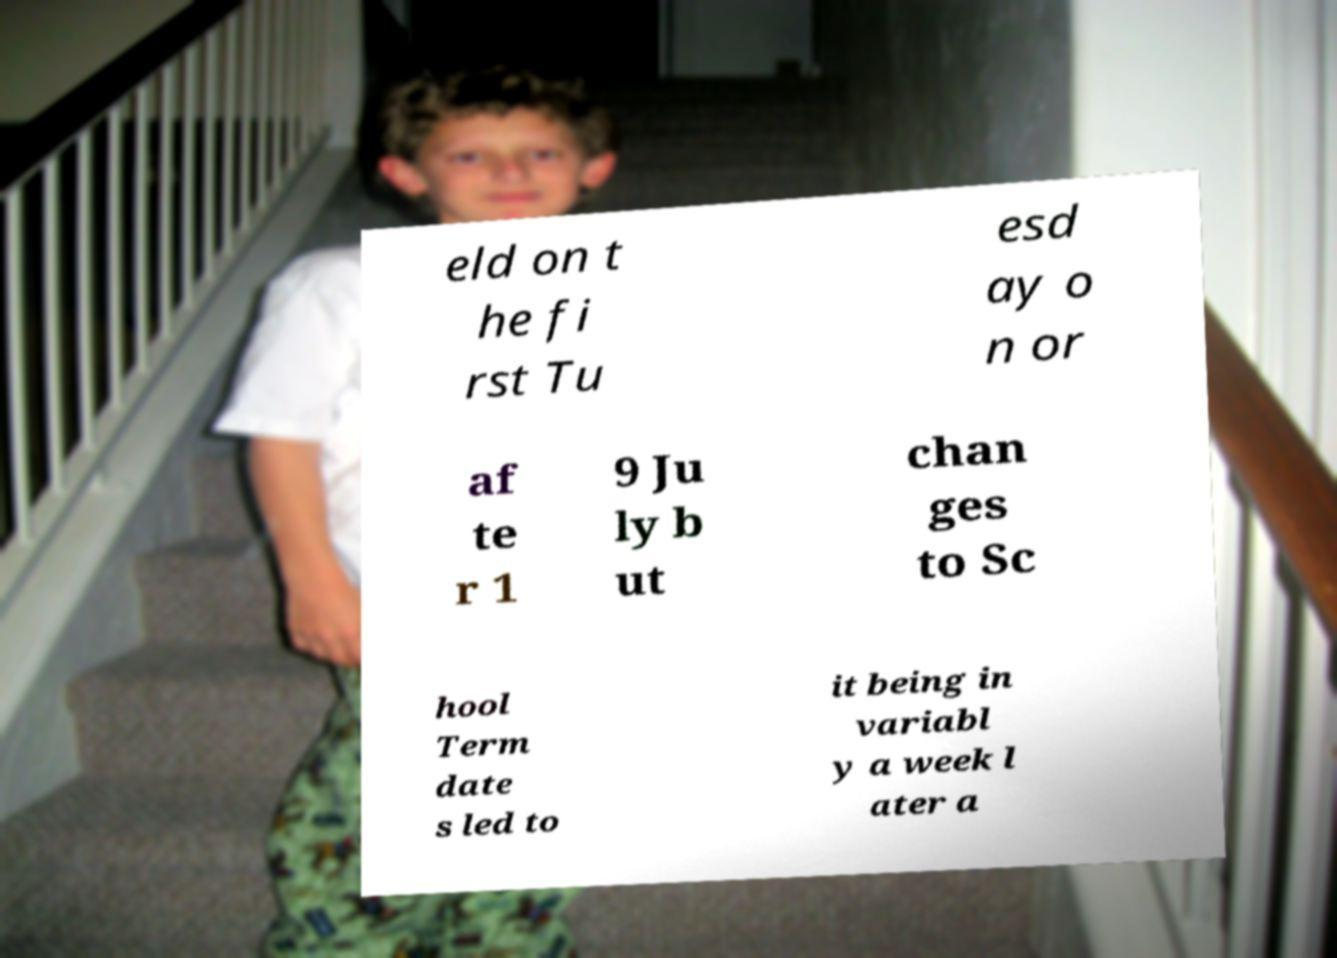There's text embedded in this image that I need extracted. Can you transcribe it verbatim? eld on t he fi rst Tu esd ay o n or af te r 1 9 Ju ly b ut chan ges to Sc hool Term date s led to it being in variabl y a week l ater a 